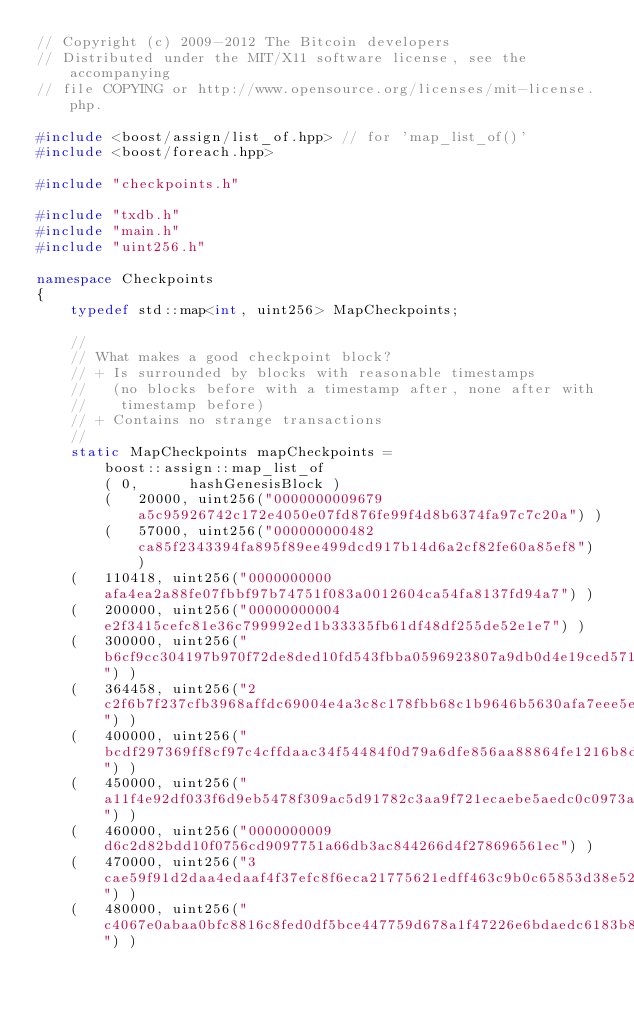<code> <loc_0><loc_0><loc_500><loc_500><_C++_>// Copyright (c) 2009-2012 The Bitcoin developers
// Distributed under the MIT/X11 software license, see the accompanying
// file COPYING or http://www.opensource.org/licenses/mit-license.php.

#include <boost/assign/list_of.hpp> // for 'map_list_of()'
#include <boost/foreach.hpp>

#include "checkpoints.h"

#include "txdb.h"
#include "main.h"
#include "uint256.h"

namespace Checkpoints
{
    typedef std::map<int, uint256> MapCheckpoints;

    //
    // What makes a good checkpoint block?
    // + Is surrounded by blocks with reasonable timestamps
    //   (no blocks before with a timestamp after, none after with
    //    timestamp before)
    // + Contains no strange transactions
    //
    static MapCheckpoints mapCheckpoints =
        boost::assign::map_list_of
        ( 0,      hashGenesisBlock )
        (   20000, uint256("0000000009679a5c95926742c172e4050e07fd876fe99f4d8b6374fa97c7c20a") )
        (   57000, uint256("000000000482ca85f2343394fa895f89ee499dcd917b14d6a2cf82fe60a85ef8") )
		(   110418, uint256("0000000000afa4ea2a88fe07fbbf97b74751f083a0012604ca54fa8137fd94a7") )
		(   200000, uint256("00000000004e2f3415cefc81e36c799992ed1b33335fb61df48df255de52e1e7") )
		(   300000, uint256("b6cf9cc304197b970f72de8ded10fd543fbba0596923807a9db0d4e19ced5710") )
		(   364458, uint256("2c2f6b7f237cfb3968affdc69004e4a3c8c178fbb68c1b9646b5630afa7eee5e") )
		(   400000, uint256("bcdf297369ff8cf97c4cffdaac34f54484f0d79a6dfe856aa88864fe1216b8df") )
		(   450000, uint256("a11f4e92df033f6d9eb5478f309ac5d91782c3aa9f721ecaebe5aedc0c0973ab") )
		(   460000, uint256("0000000009d6c2d82bdd10f0756cd9097751a66db3ac844266d4f278696561ec") )
		(   470000, uint256("3cae59f91d2daa4edaaf4f37efc8f6eca21775621edff463c9b0c65853d38e52") )
		(   480000, uint256("c4067e0abaa0bfc8816c8fed0df5bce447759d678a1f47226e6bdaedc6183b8c") )</code> 